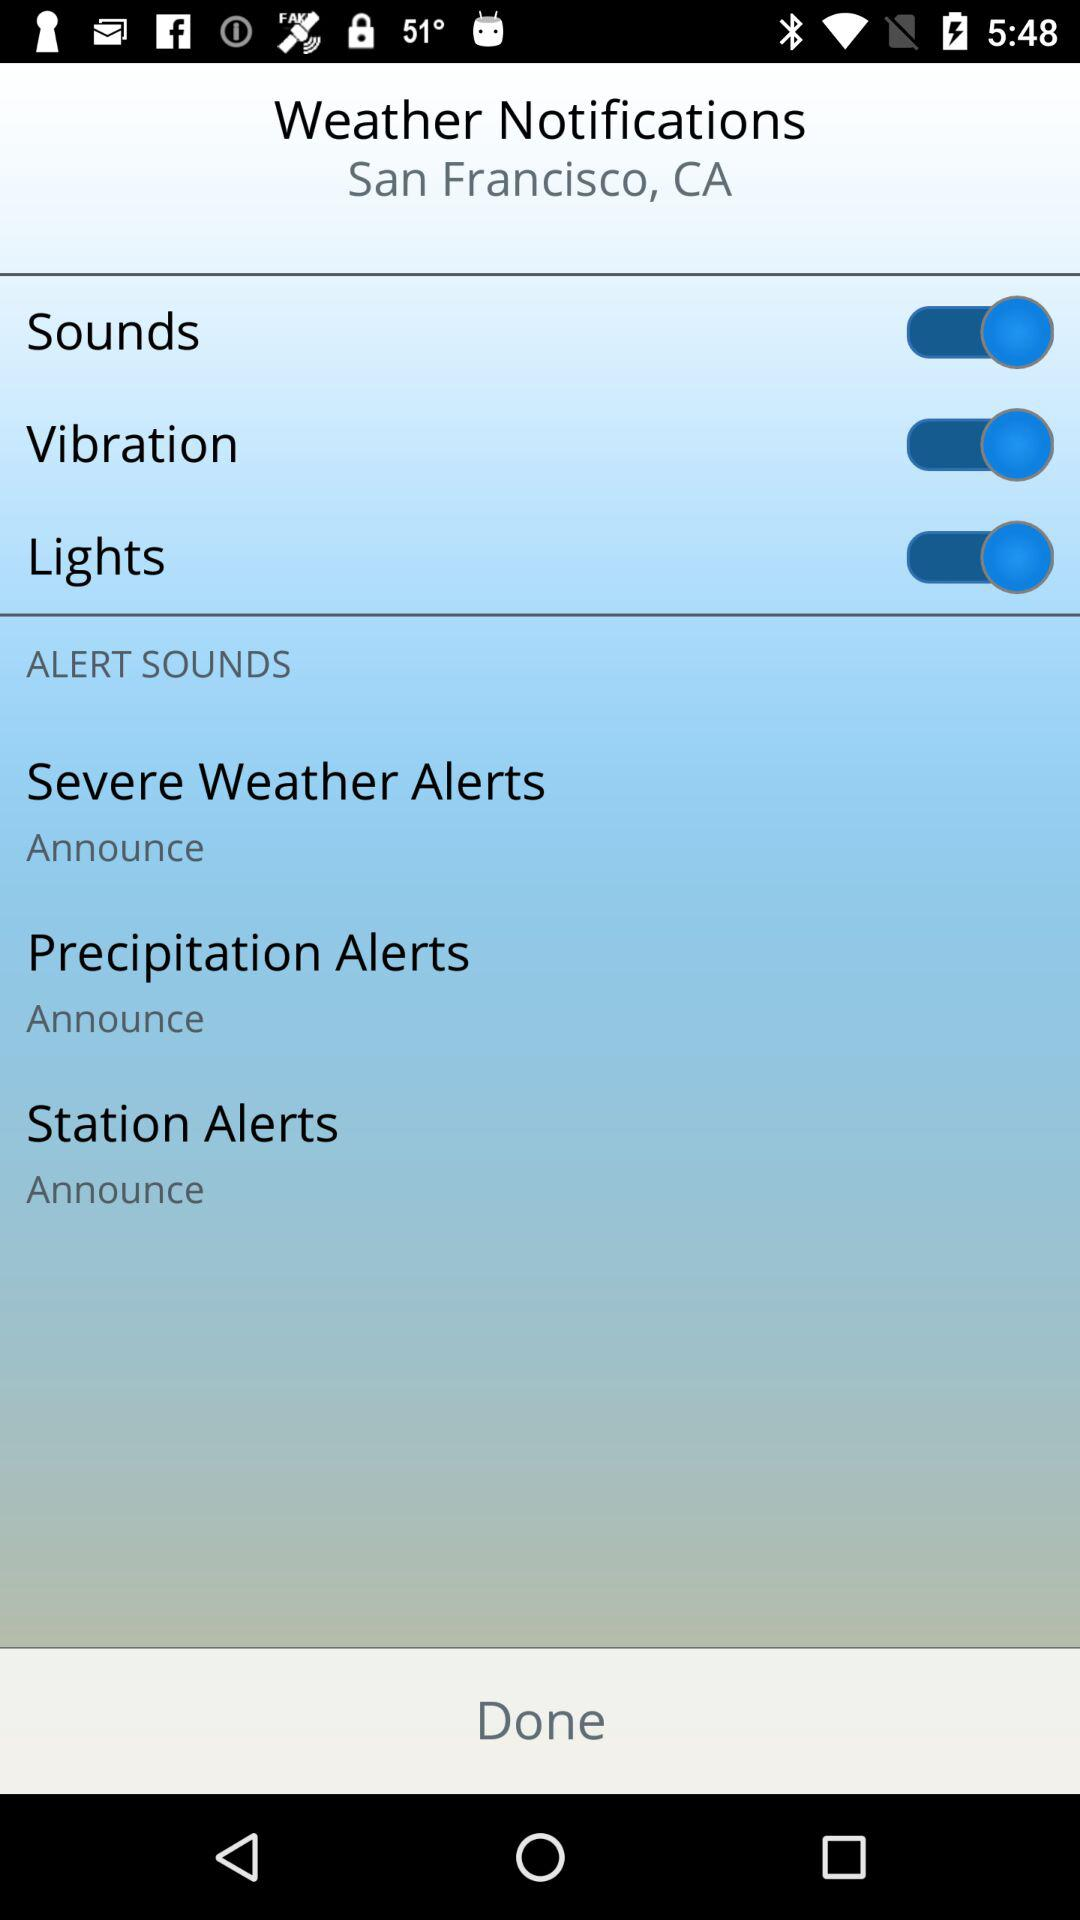What is the setting for station alerts? The setting is "Announce". 